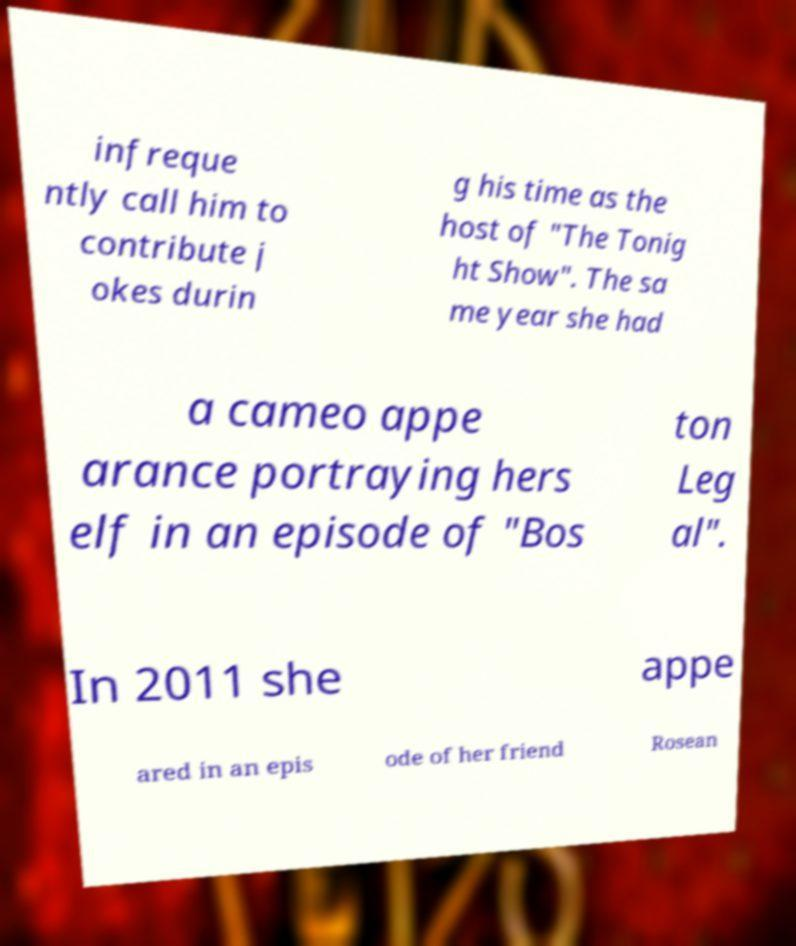Could you assist in decoding the text presented in this image and type it out clearly? infreque ntly call him to contribute j okes durin g his time as the host of "The Tonig ht Show". The sa me year she had a cameo appe arance portraying hers elf in an episode of "Bos ton Leg al". In 2011 she appe ared in an epis ode of her friend Rosean 